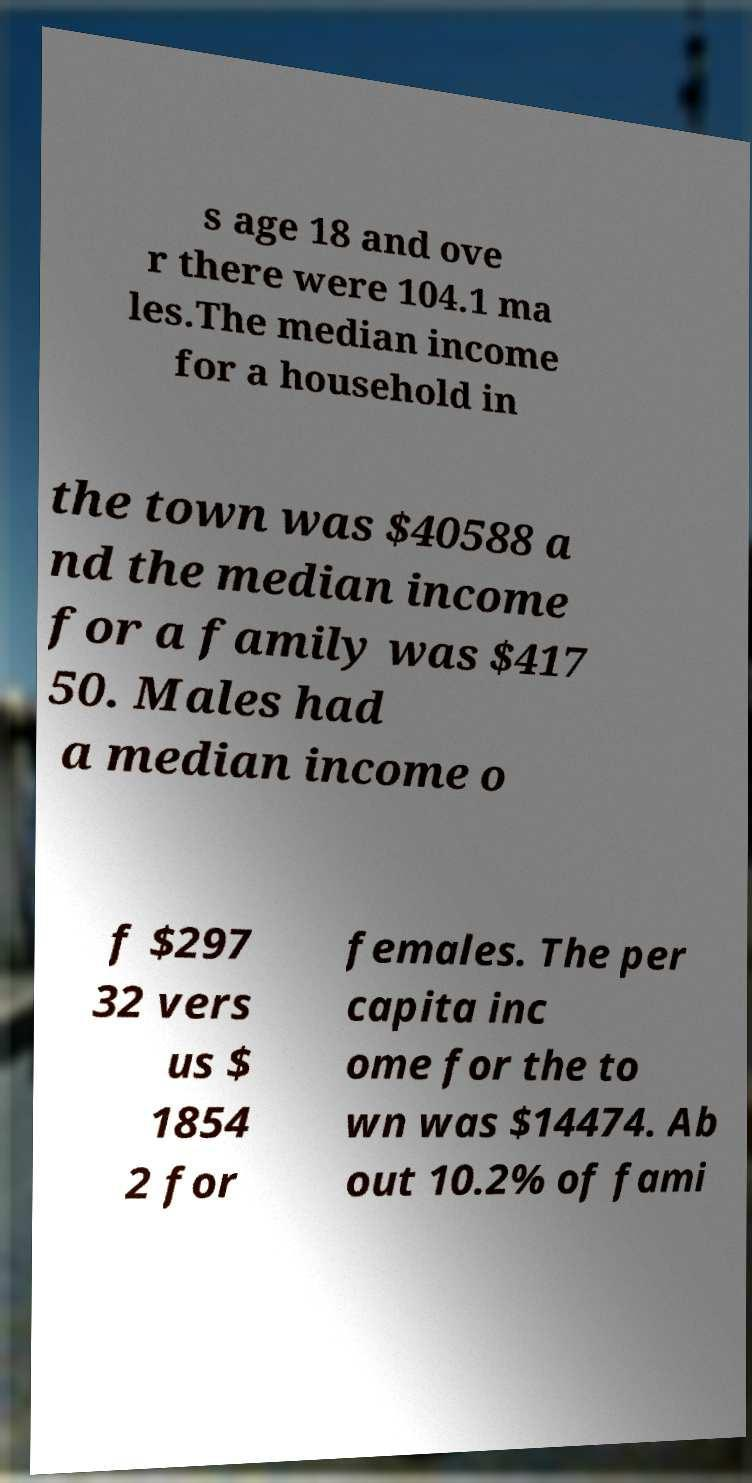There's text embedded in this image that I need extracted. Can you transcribe it verbatim? s age 18 and ove r there were 104.1 ma les.The median income for a household in the town was $40588 a nd the median income for a family was $417 50. Males had a median income o f $297 32 vers us $ 1854 2 for females. The per capita inc ome for the to wn was $14474. Ab out 10.2% of fami 